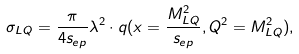Convert formula to latex. <formula><loc_0><loc_0><loc_500><loc_500>\sigma _ { L Q } = \frac { \pi } { 4 s _ { e p } } \lambda ^ { 2 } \cdot q ( x = \frac { M ^ { 2 } _ { L Q } } { s _ { e p } } , Q ^ { 2 } = M ^ { 2 } _ { L Q } ) ,</formula> 